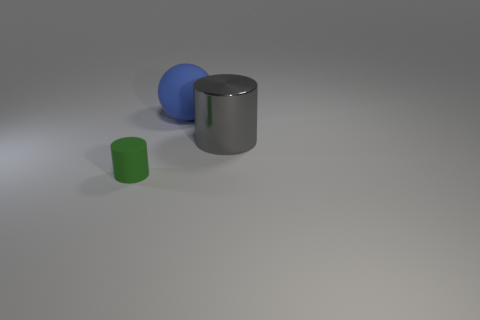What number of large blue rubber balls are there?
Offer a very short reply. 1. What color is the matte object that is behind the green rubber cylinder?
Make the answer very short. Blue. The gray metallic cylinder has what size?
Your response must be concise. Large. There is a small rubber thing; is it the same color as the big object behind the large gray metal object?
Keep it short and to the point. No. There is a large object behind the cylinder behind the green cylinder; what is its color?
Provide a succinct answer. Blue. Are there any other things that have the same size as the blue matte ball?
Your response must be concise. Yes. There is a rubber object that is in front of the big blue ball; is its shape the same as the gray metal object?
Give a very brief answer. Yes. What number of things are right of the small rubber thing and in front of the large matte sphere?
Ensure brevity in your answer.  1. There is a matte thing on the right side of the green cylinder on the left side of the large thing to the left of the big gray shiny cylinder; what color is it?
Provide a succinct answer. Blue. What number of large blue rubber balls are left of the matte object that is on the right side of the small rubber object?
Ensure brevity in your answer.  0. 